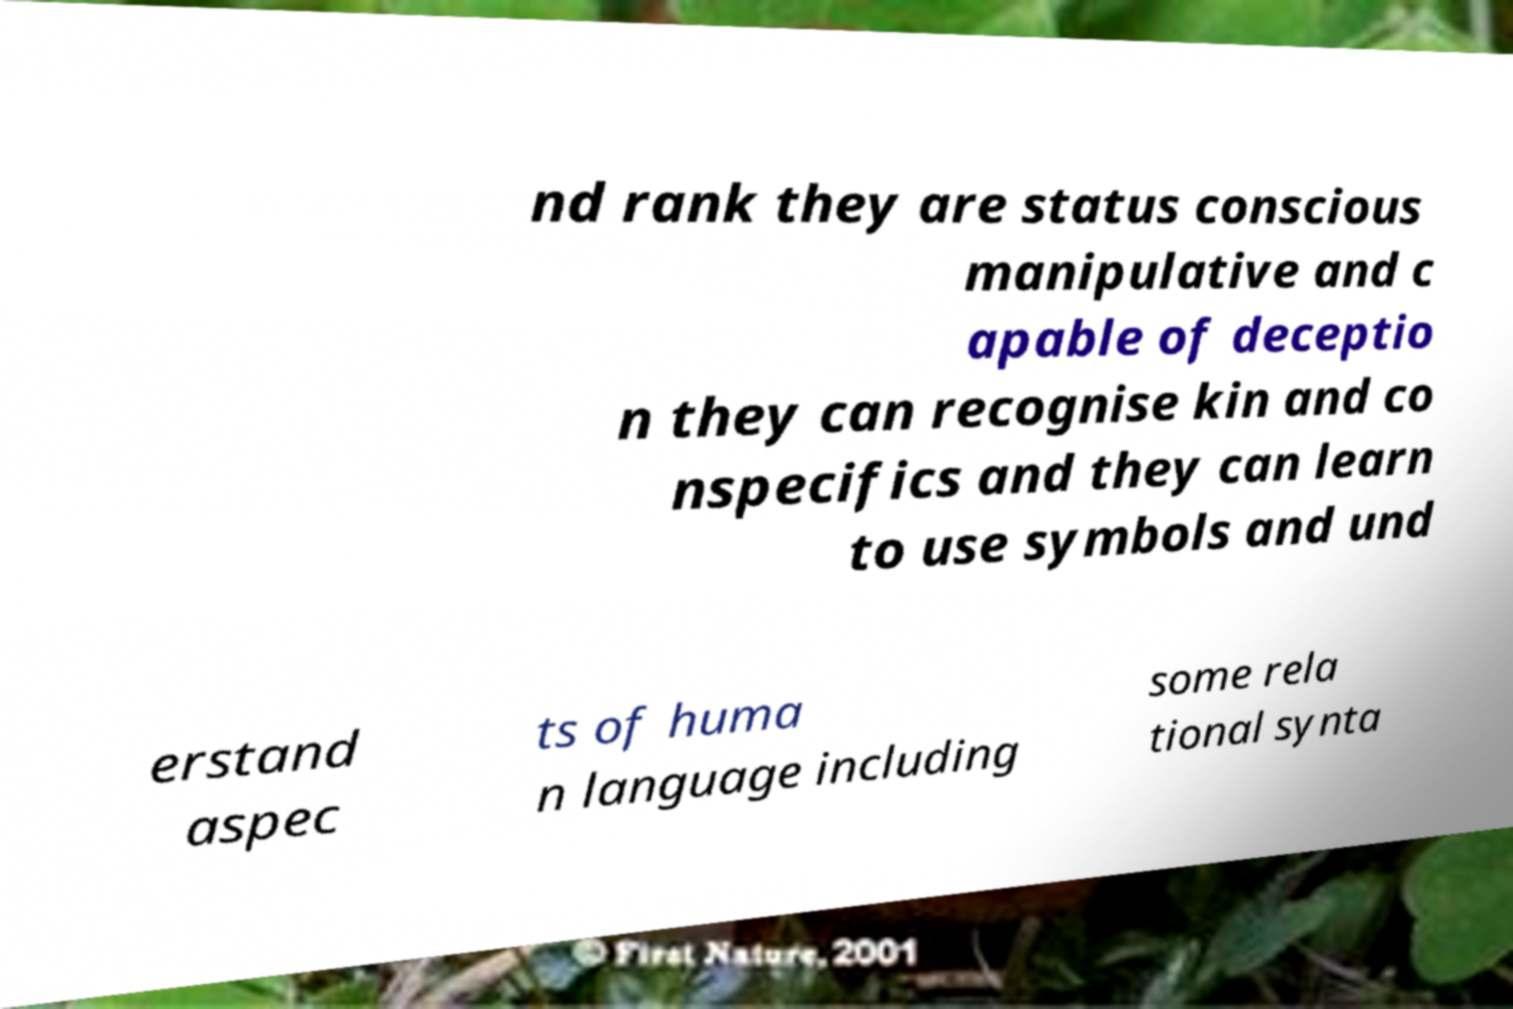Can you accurately transcribe the text from the provided image for me? nd rank they are status conscious manipulative and c apable of deceptio n they can recognise kin and co nspecifics and they can learn to use symbols and und erstand aspec ts of huma n language including some rela tional synta 